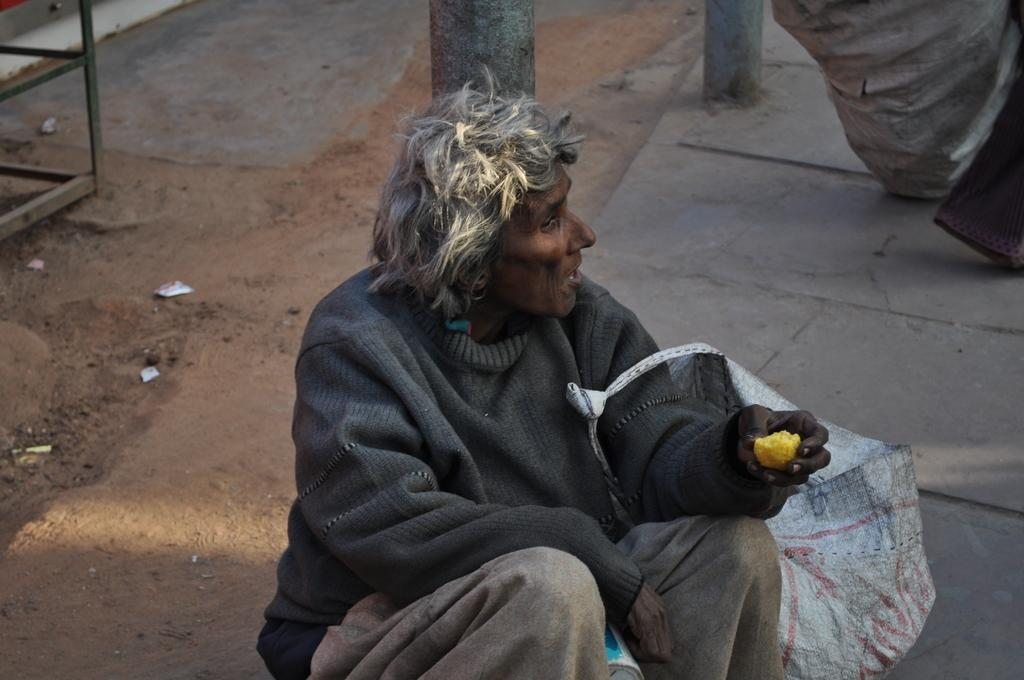What is the person in the image doing? There is a person sitting in the image. What is the person holding? The person is holding a food item. What can be seen in the background of the image? There is a bag, poles, and a steel rack in the background of the image. Can you see any veins on the person's hand in the image? There is no information about the person's hand or veins in the image, so it cannot be determined. 